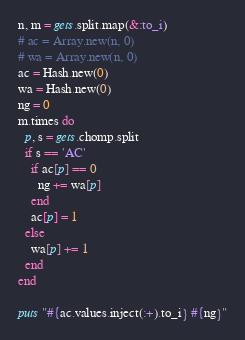<code> <loc_0><loc_0><loc_500><loc_500><_Ruby_>n, m = gets.split.map(&:to_i)
# ac = Array.new(n, 0)
# wa = Array.new(n, 0)
ac = Hash.new(0)
wa = Hash.new(0)
ng = 0
m.times do
  p, s = gets.chomp.split
  if s == 'AC'
    if ac[p] == 0
      ng += wa[p]
    end
    ac[p] = 1    
  else
    wa[p] += 1
  end
end

puts "#{ac.values.inject(:+).to_i} #{ng}"</code> 